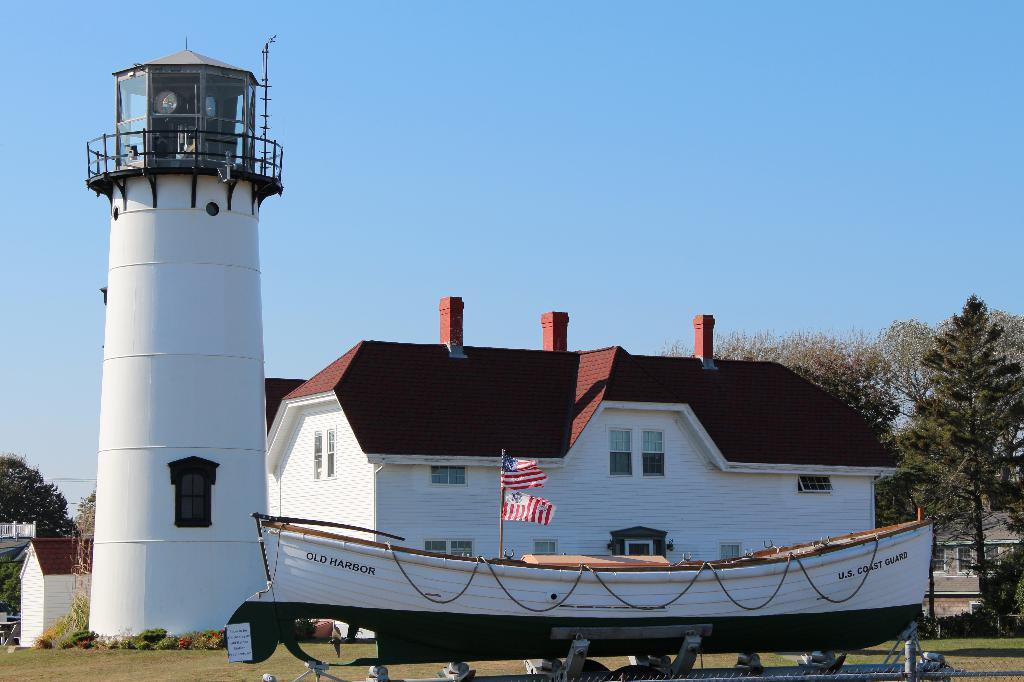What color is the wall in the image? The wall in the image is white. What color is the roof top in the image? The roof top in the image is red. What can be seen hanging or attached in the image? There is a banner in the image. What type of vegetation is present in the image? There is grass and trees in the image. What is visible at the top of the image? The sky is visible at the top of the image. Is there any poison visible in the image? There is no poison present in the image. Can you see the person's brother in the image? There is no person or brother mentioned in the provided facts, so it cannot be determined from the image. 